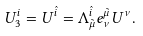<formula> <loc_0><loc_0><loc_500><loc_500>U _ { 3 } ^ { i } = U ^ { \hat { i } } = \Lambda ^ { \hat { i } } _ { \tilde { \mu } } e ^ { \tilde { \mu } } _ { \nu } U ^ { \nu } .</formula> 